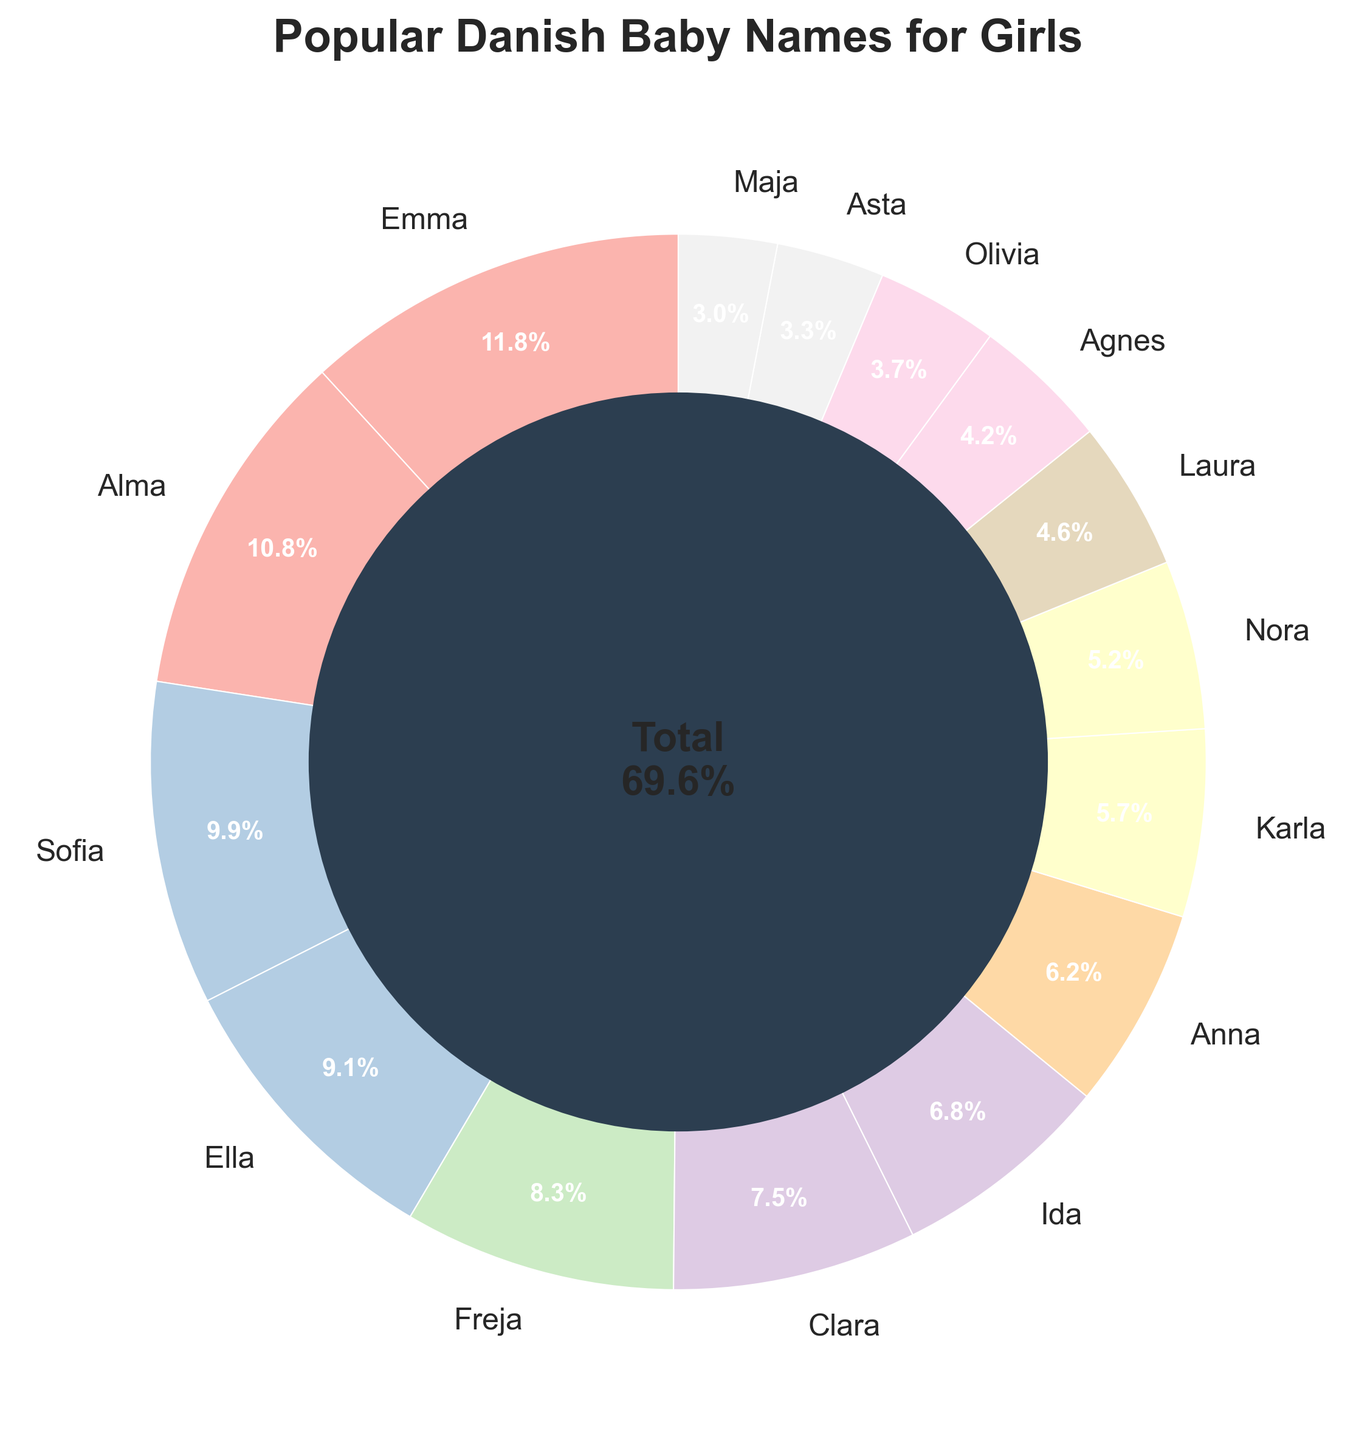What is the most popular Danish baby name for girls? The pie chart shows the percentages of different baby names. Emma has the highest percentage at 8.2%.
Answer: Emma How many names have a percentage above 5%? By visually inspecting the pie chart, the names above 5% are Emma, Alma, Sofia, Ella, and Freja. There are 5 of them in total.
Answer: 5 What is the combined percentage of the names Alma and Clara? Alma has a percentage of 7.5% and Clara has 5.2%. Adding them together gives 7.5% + 5.2% = 12.7%.
Answer: 12.7% Which name is less popular, Nora or Laura? Nora has a percentage of 3.6% while Laura has 3.2%. Since 3.2% is less than 3.6%, Laura is less popular.
Answer: Laura What is the total percentage of the three least popular names? The three least popular names are Asta (2.3%), Maja (2.1%), and Olivia (2.6%). Their combined percentage is 2.3% + 2.1% + 2.6% = 7.0%.
Answer: 7.0% Can you find the difference in popularity between the most and least popular names? Emma is the most popular at 8.2%, and Maja is the least with 2.1%. The difference is 8.2% - 2.1% = 6.1%.
Answer: 6.1% What is the total percentage of names starting with 'A'? The names starting with 'A' are Alma (7.5%), Anna (4.3%), Agnes (2.9%), and Asta (2.3%). Adding them: 7.5% + 4.3% + 2.9% + 2.3% = 17.0%.
Answer: 17.0% How many names have a percentage lower than 4%? By visual inspection, the names lower than 4% are Karla, Nora, Laura, Agnes, Olivia, Asta, and Maja. There are 7 names in total.
Answer: 7 What is the average percentage of the top three baby names? The top three names are Emma (8.2%), Alma (7.5%), and Sofia (6.9%). Their average is (8.2% + 7.5% + 6.9%) / 3 = 7.53%.
Answer: 7.5% If the names Emma, Alma, and Sofia are combined into a group, what percentage of the total do they represent? Combining Emma (8.2%), Alma (7.5%), and Sofia (6.9%): 8.2% + 7.5% + 6.9% = 22.6%.
Answer: 22.6% 